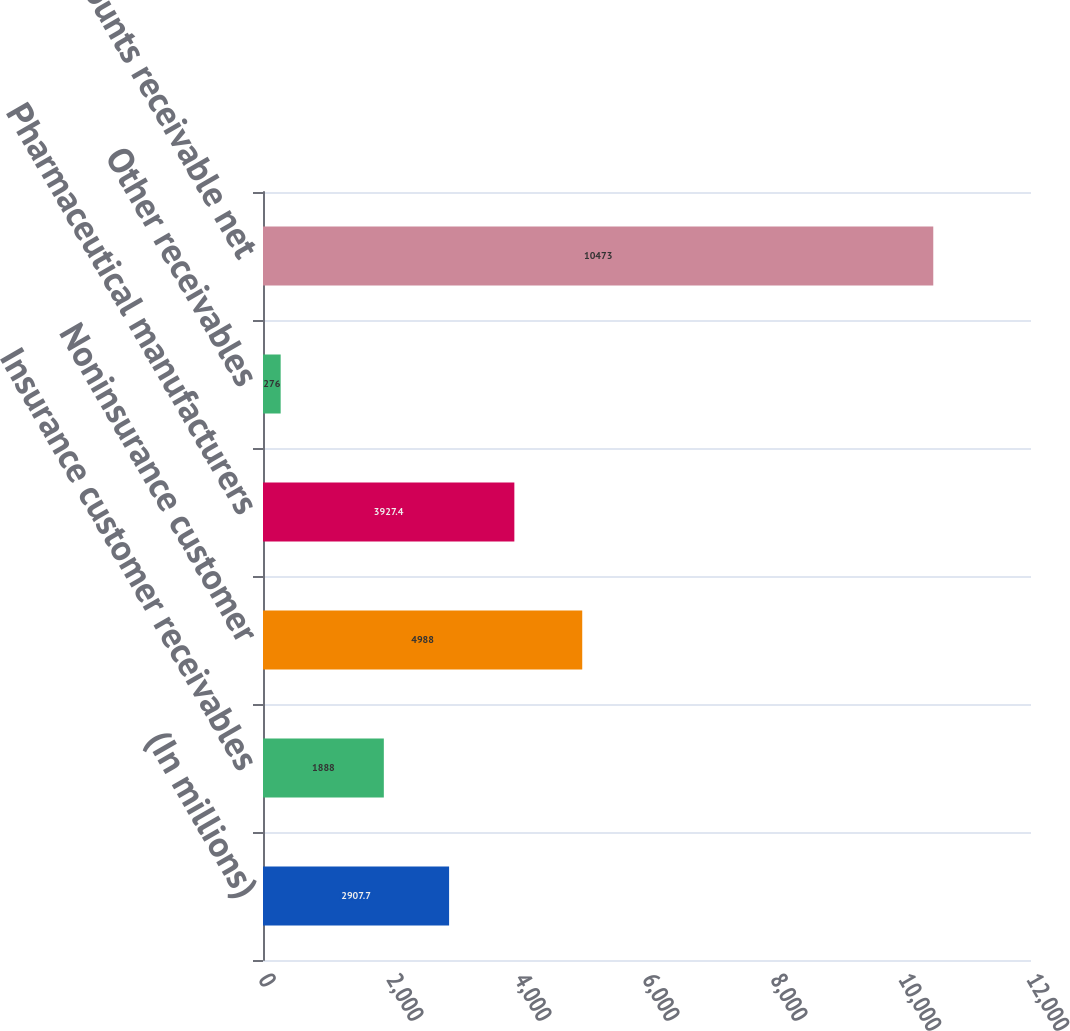Convert chart to OTSL. <chart><loc_0><loc_0><loc_500><loc_500><bar_chart><fcel>(In millions)<fcel>Insurance customer receivables<fcel>Noninsurance customer<fcel>Pharmaceutical manufacturers<fcel>Other receivables<fcel>Total accounts receivable net<nl><fcel>2907.7<fcel>1888<fcel>4988<fcel>3927.4<fcel>276<fcel>10473<nl></chart> 